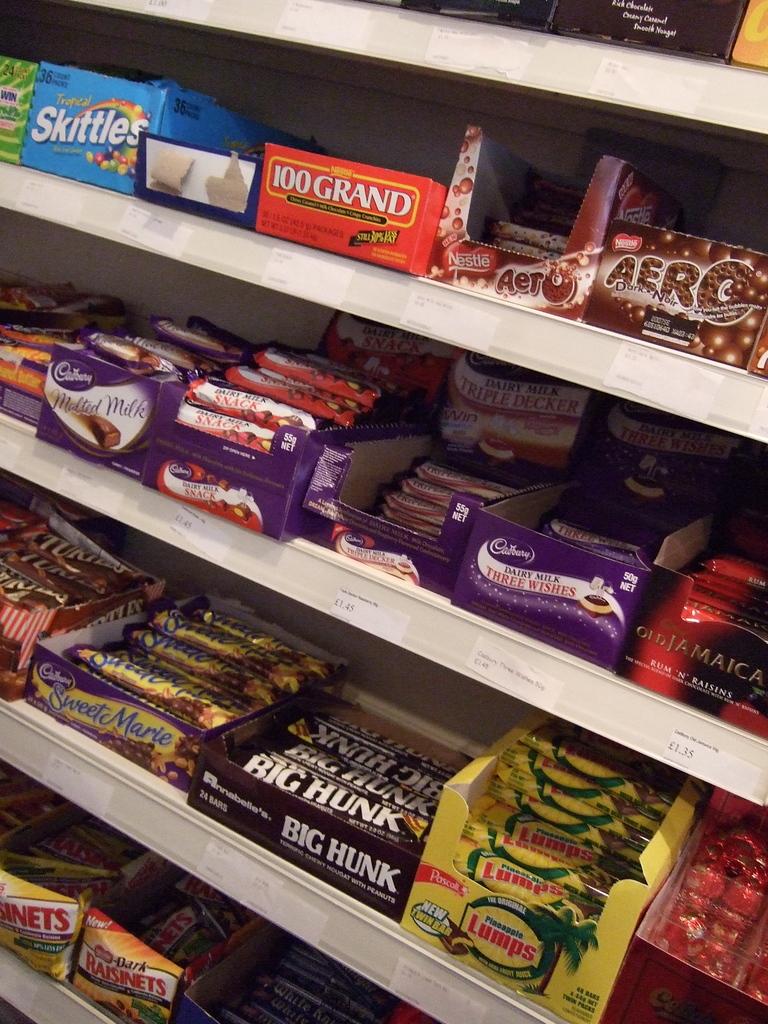What is the name of the blue box of candy?
Provide a short and direct response. Skittles. What type of candy bar is in the black box with white letters?
Your response must be concise. Big hunk. 